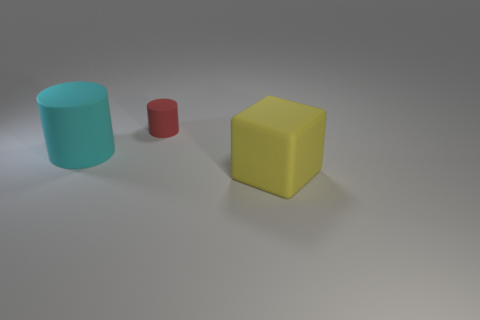How many other objects are there of the same material as the big cyan thing?
Give a very brief answer. 2. How many metallic objects are either cyan cylinders or big things?
Ensure brevity in your answer.  0. There is another big thing that is the same shape as the red matte object; what color is it?
Offer a terse response. Cyan. How many things are either large matte things or yellow objects?
Offer a very short reply. 2. There is a big thing that is made of the same material as the large yellow cube; what is its shape?
Give a very brief answer. Cylinder. How many big things are either red rubber cylinders or matte things?
Provide a succinct answer. 2. How many other things are the same color as the small cylinder?
Your response must be concise. 0. What number of things are behind the big thing on the left side of the big rubber object that is on the right side of the small rubber cylinder?
Offer a terse response. 1. Does the cylinder on the left side of the red object have the same size as the cube?
Your answer should be very brief. Yes. Are there fewer rubber cylinders that are in front of the cyan matte cylinder than tiny things in front of the tiny red cylinder?
Your answer should be compact. No. 